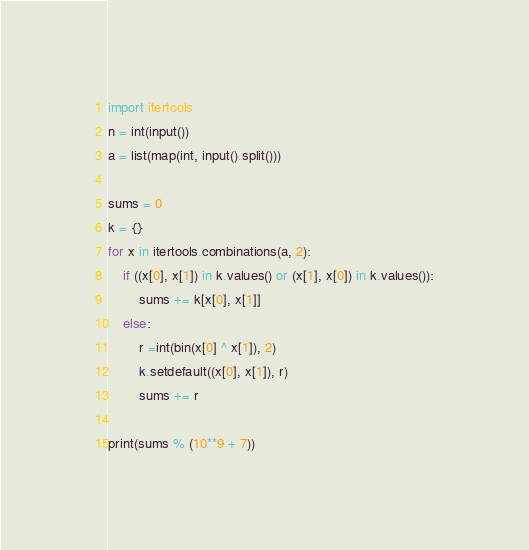Convert code to text. <code><loc_0><loc_0><loc_500><loc_500><_Python_>import itertools
n = int(input())
a = list(map(int, input().split()))

sums = 0
k = {}
for x in itertools.combinations(a, 2):
    if ((x[0], x[1]) in k.values() or (x[1], x[0]) in k.values()):
        sums += k[x[0], x[1]]
    else:
        r =int(bin(x[0] ^ x[1]), 2)
        k.setdefault((x[0], x[1]), r)
        sums += r

print(sums % (10**9 + 7))</code> 